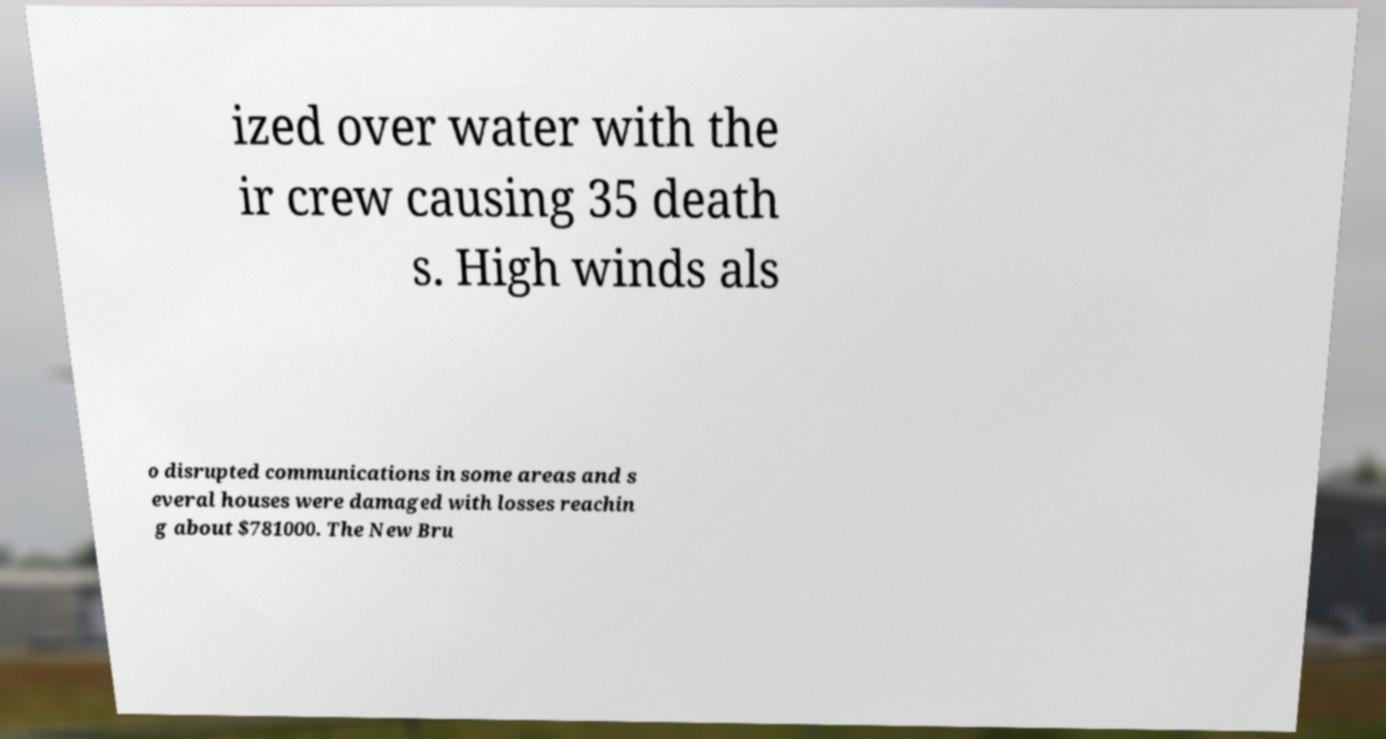Can you read and provide the text displayed in the image?This photo seems to have some interesting text. Can you extract and type it out for me? ized over water with the ir crew causing 35 death s. High winds als o disrupted communications in some areas and s everal houses were damaged with losses reachin g about $781000. The New Bru 